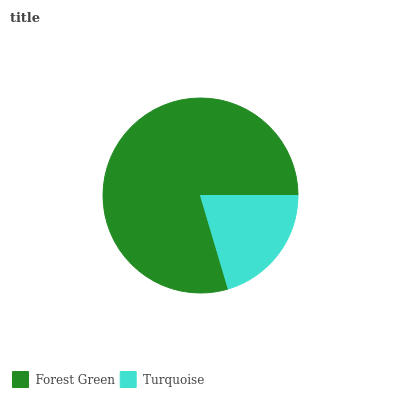Is Turquoise the minimum?
Answer yes or no. Yes. Is Forest Green the maximum?
Answer yes or no. Yes. Is Turquoise the maximum?
Answer yes or no. No. Is Forest Green greater than Turquoise?
Answer yes or no. Yes. Is Turquoise less than Forest Green?
Answer yes or no. Yes. Is Turquoise greater than Forest Green?
Answer yes or no. No. Is Forest Green less than Turquoise?
Answer yes or no. No. Is Forest Green the high median?
Answer yes or no. Yes. Is Turquoise the low median?
Answer yes or no. Yes. Is Turquoise the high median?
Answer yes or no. No. Is Forest Green the low median?
Answer yes or no. No. 